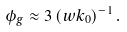<formula> <loc_0><loc_0><loc_500><loc_500>\phi _ { g } \approx 3 \, ( w k _ { 0 } ) ^ { - 1 } \, .</formula> 